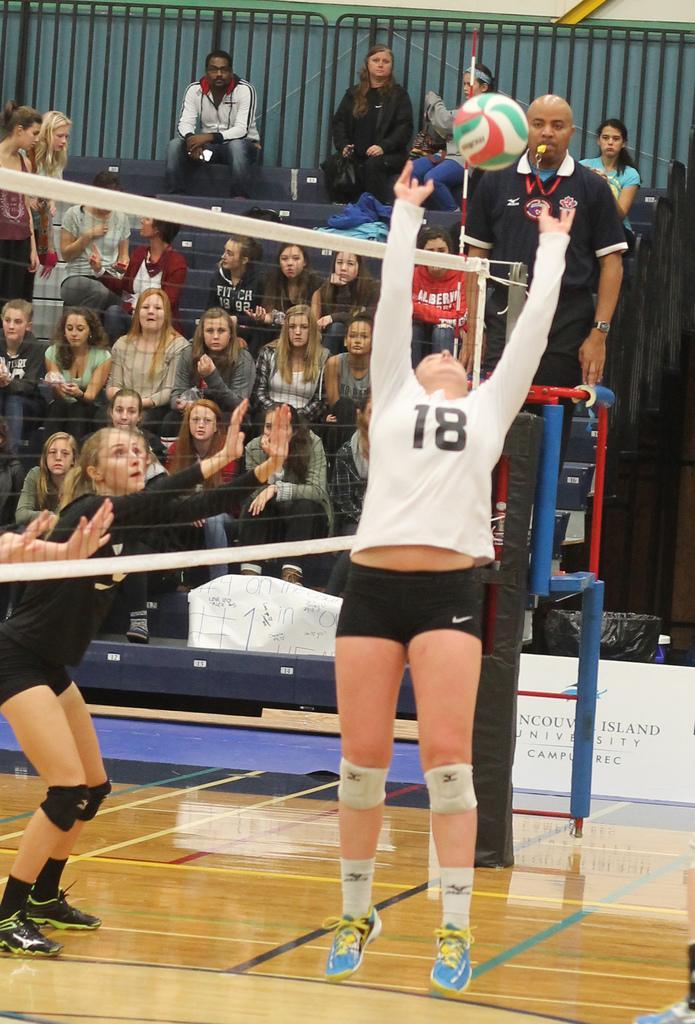Please provide a concise description of this image. There are people playing volleyball and a net in the foreground area of the image, there are people sitting, a man holding a whistle in his mouth, poster, it seems like a boundary in the background. 